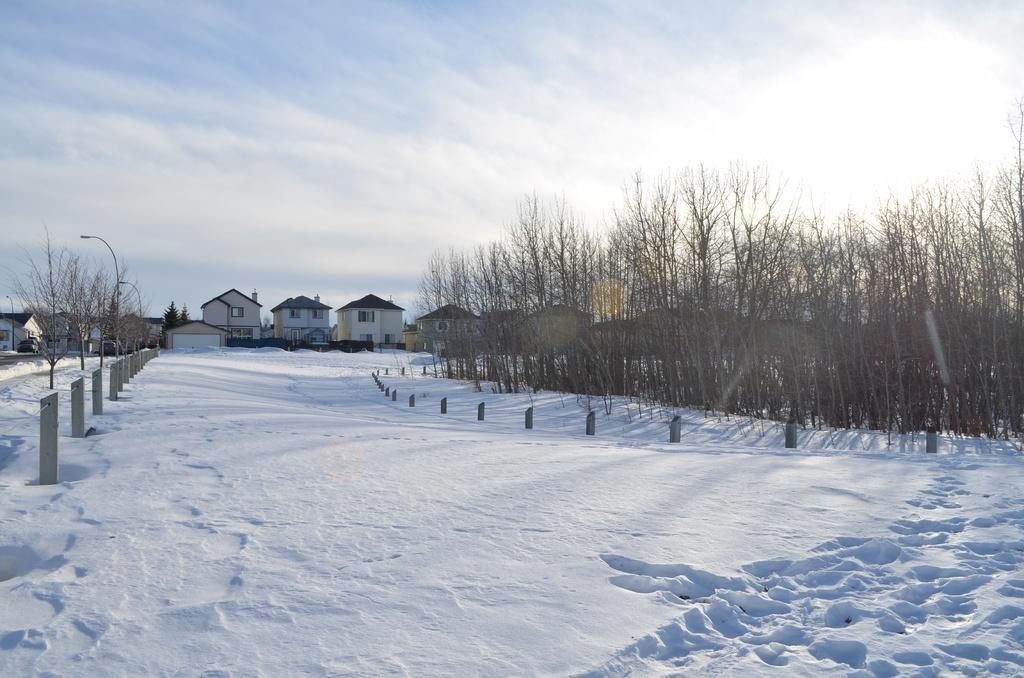What is the condition of the ground in the image? The ground is covered with snow. What type of structures can be seen in the image? There are houses in the image. What else can be seen in the image besides houses? There are poles, trees, and a vehicle in the image. What is visible in the sky in the image? The sky is visible with clouds in the image. What type of secretary can be seen sitting on the vehicle in the image? There is no secretary present in the image, and the vehicle does not have any visible occupants. 